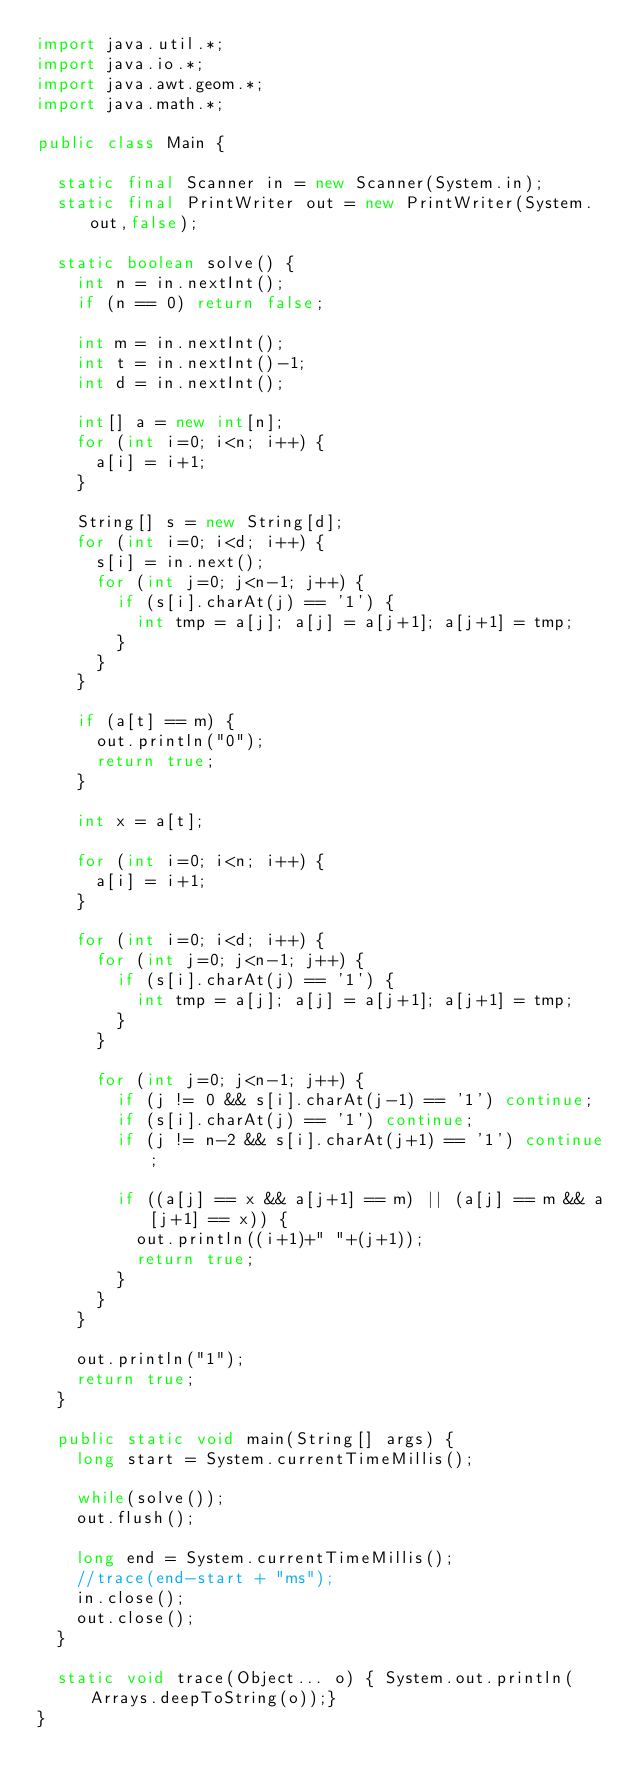<code> <loc_0><loc_0><loc_500><loc_500><_Java_>import java.util.*;
import java.io.*;
import java.awt.geom.*;
import java.math.*;

public class Main {

	static final Scanner in = new Scanner(System.in);
	static final PrintWriter out = new PrintWriter(System.out,false);

	static boolean solve() {
		int n = in.nextInt();
		if (n == 0) return false;

		int m = in.nextInt();
		int t = in.nextInt()-1;
		int d = in.nextInt();

		int[] a = new int[n];
		for (int i=0; i<n; i++) {
			a[i] = i+1;
		}

		String[] s = new String[d];
		for (int i=0; i<d; i++) {
			s[i] = in.next();
			for (int j=0; j<n-1; j++) {
				if (s[i].charAt(j) == '1') {
					int tmp = a[j]; a[j] = a[j+1]; a[j+1] = tmp;
				}
			}
		}

		if (a[t] == m) {
			out.println("0");
			return true;
		}

		int x = a[t];

		for (int i=0; i<n; i++) {
			a[i] = i+1;
		}

		for (int i=0; i<d; i++) {
			for (int j=0; j<n-1; j++) {
				if (s[i].charAt(j) == '1') {
					int tmp = a[j]; a[j] = a[j+1]; a[j+1] = tmp;
				}
			}

			for (int j=0; j<n-1; j++) {
				if (j != 0 && s[i].charAt(j-1) == '1') continue;
				if (s[i].charAt(j) == '1') continue;
				if (j != n-2 && s[i].charAt(j+1) == '1') continue;

				if ((a[j] == x && a[j+1] == m) || (a[j] == m && a[j+1] == x)) {
					out.println((i+1)+" "+(j+1));
					return true;
				}
			}
		}

		out.println("1");
		return true;
	}

	public static void main(String[] args) {
		long start = System.currentTimeMillis();

		while(solve());
		out.flush();

		long end = System.currentTimeMillis();
		//trace(end-start + "ms");
		in.close();
		out.close();
	}

	static void trace(Object... o) { System.out.println(Arrays.deepToString(o));}
}</code> 